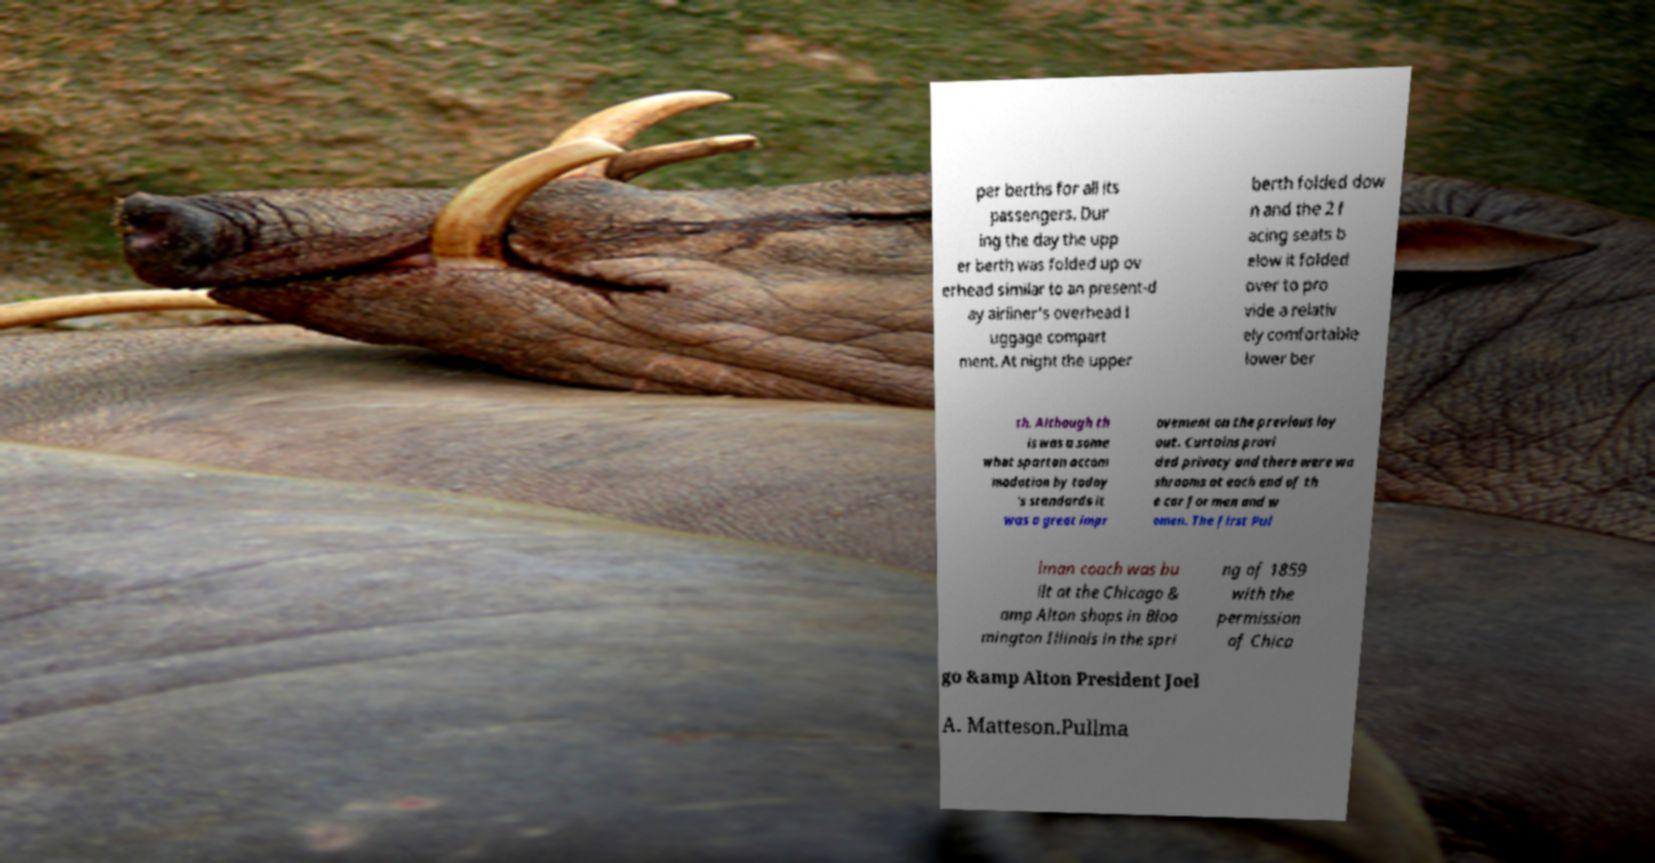For documentation purposes, I need the text within this image transcribed. Could you provide that? per berths for all its passengers. Dur ing the day the upp er berth was folded up ov erhead similar to an present-d ay airliner's overhead l uggage compart ment. At night the upper berth folded dow n and the 2 f acing seats b elow it folded over to pro vide a relativ ely comfortable lower ber th. Although th is was a some what spartan accom modation by today 's standards it was a great impr ovement on the previous lay out. Curtains provi ded privacy and there were wa shrooms at each end of th e car for men and w omen. The first Pul lman coach was bu ilt at the Chicago & amp Alton shops in Bloo mington Illinois in the spri ng of 1859 with the permission of Chica go &amp Alton President Joel A. Matteson.Pullma 